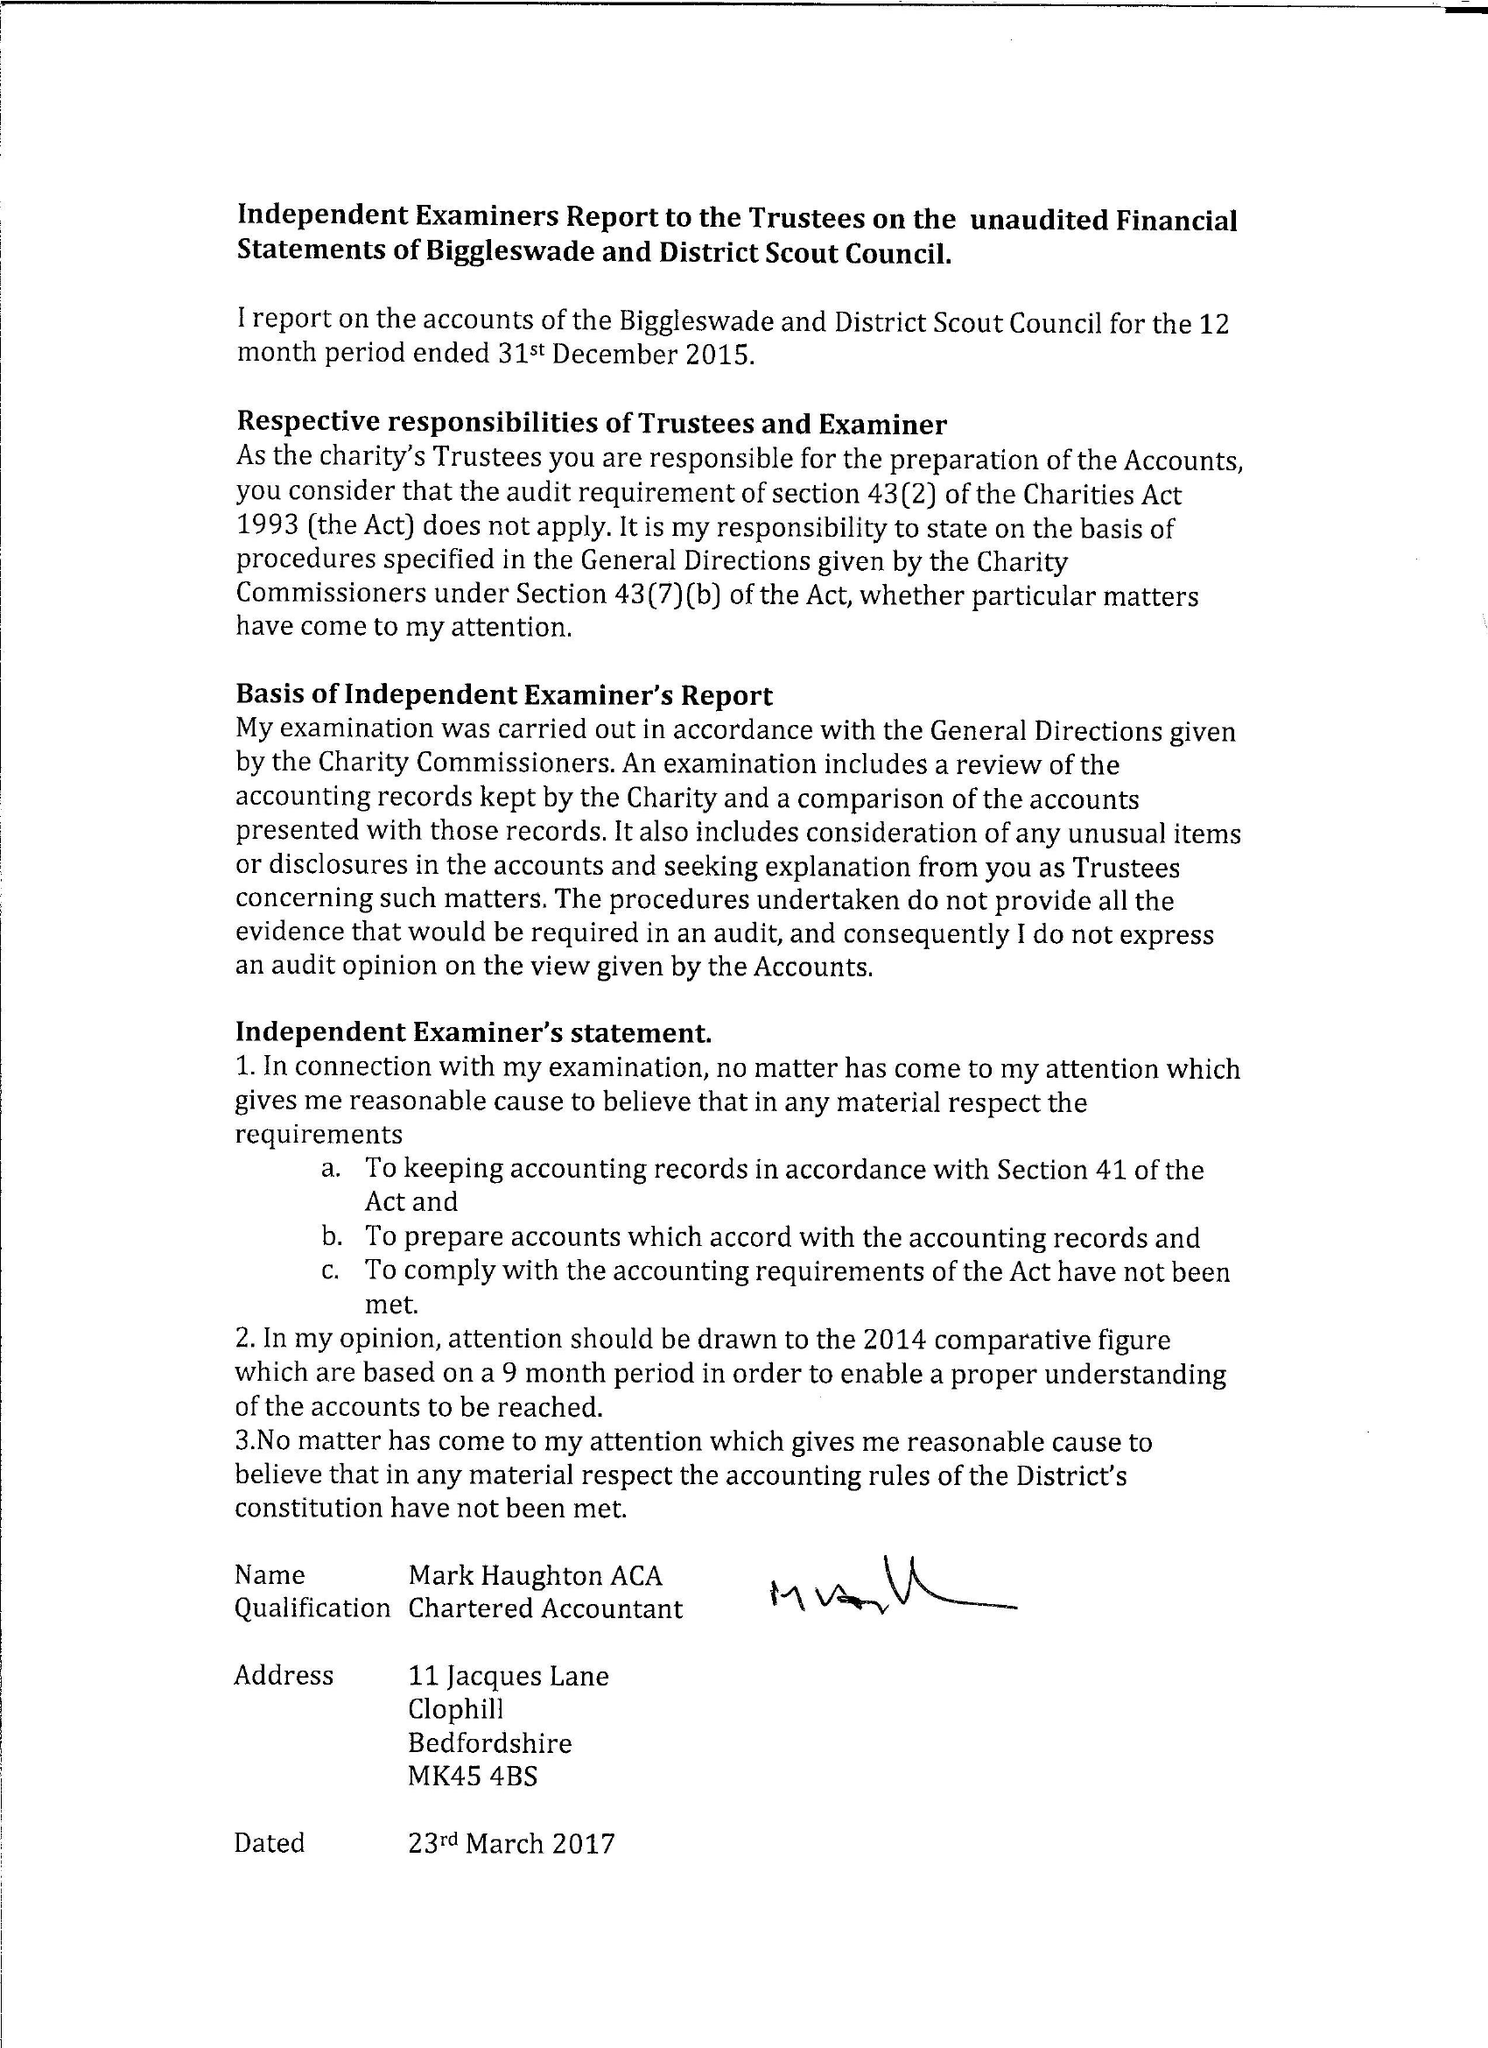What is the value for the charity_name?
Answer the question using a single word or phrase. Biggleswade District Scout Council 